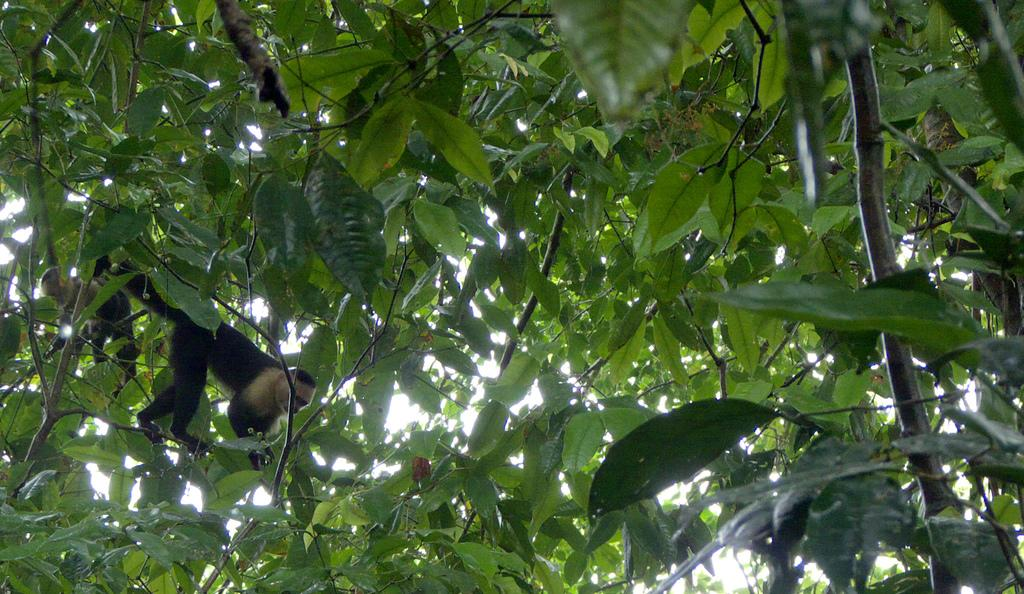What animal is present in the image? There is a monkey in the picture. Where is the monkey located? The monkey is on a tree. What type of trouble are the boys causing with the tomatoes in the image? There are no boys or tomatoes present in the image; it only features a monkey on a tree. 